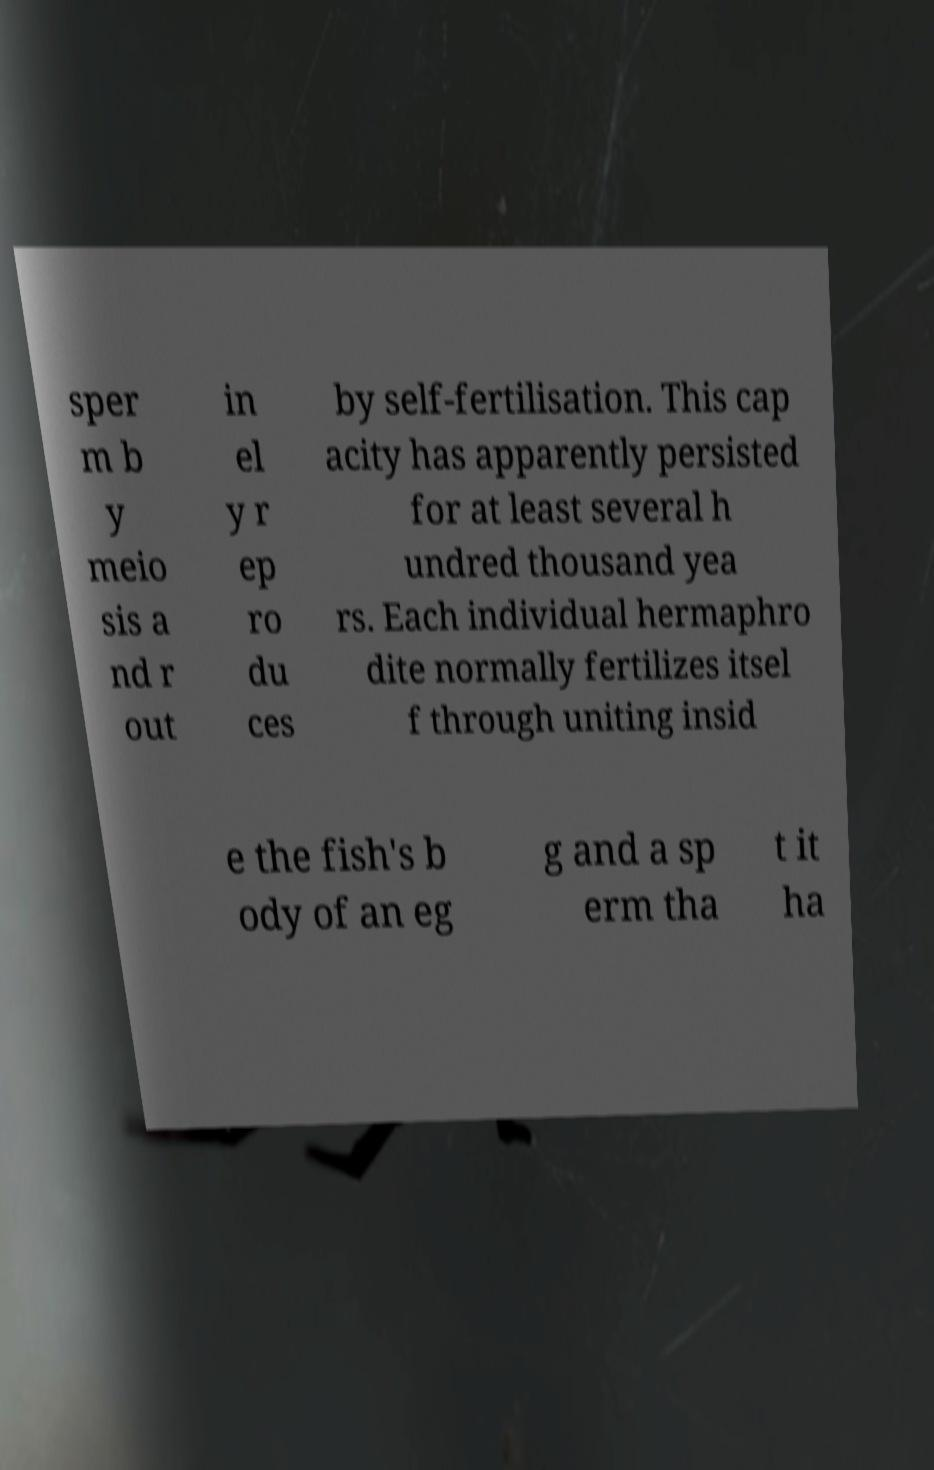Could you assist in decoding the text presented in this image and type it out clearly? sper m b y meio sis a nd r out in el y r ep ro du ces by self-fertilisation. This cap acity has apparently persisted for at least several h undred thousand yea rs. Each individual hermaphro dite normally fertilizes itsel f through uniting insid e the fish's b ody of an eg g and a sp erm tha t it ha 